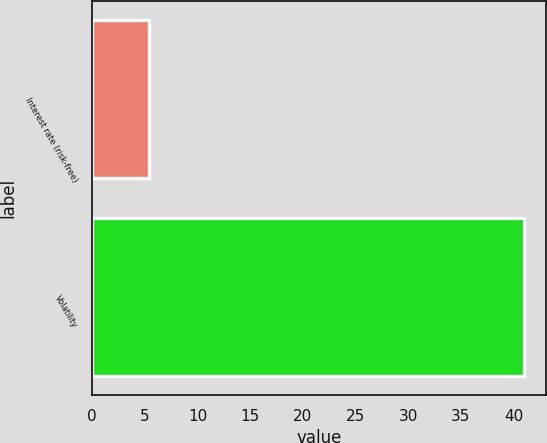<chart> <loc_0><loc_0><loc_500><loc_500><bar_chart><fcel>Interest rate (risk-free)<fcel>Volatility<nl><fcel>5.4<fcel>41<nl></chart> 